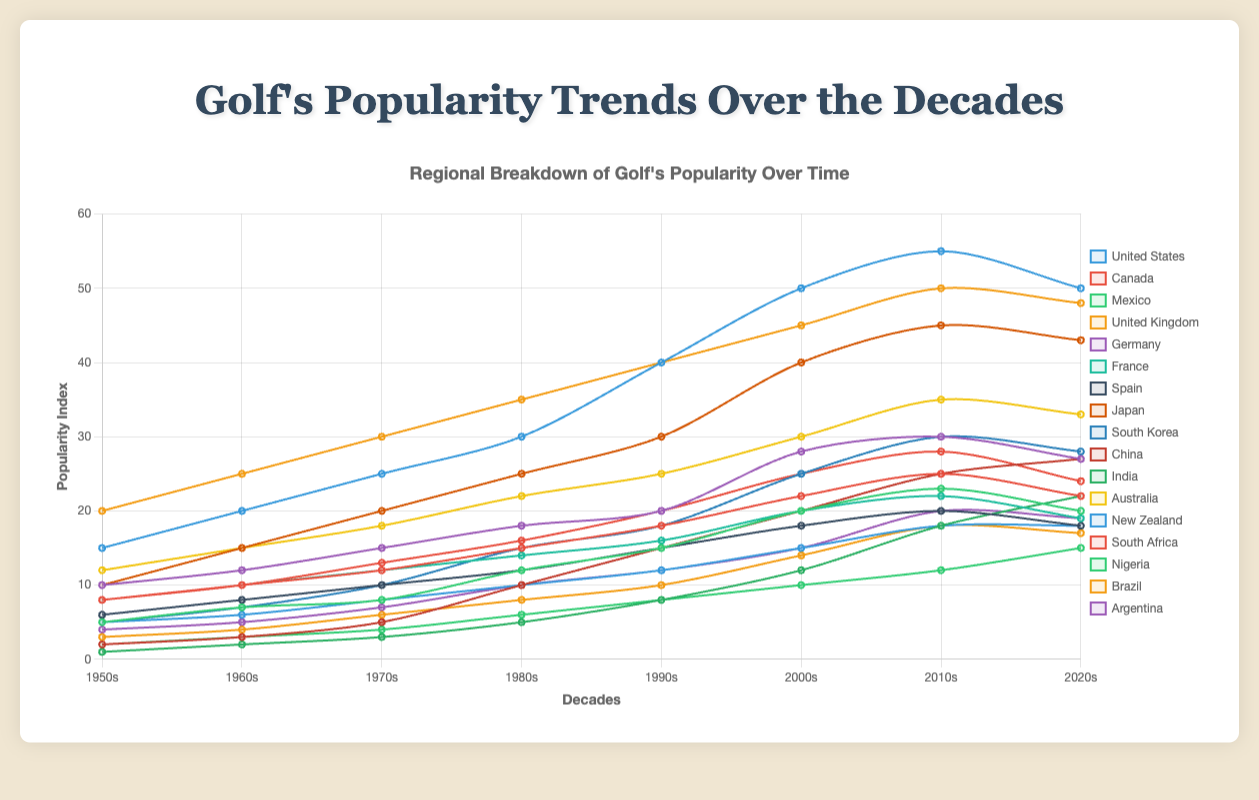What is the general trend of golf's popularity in the United States from the 1950s to the 2020s? From the 1950s to the 2000s, golf's popularity in the United States shows a steady increase, peaking in the 2010s, then slightly declining in the 2020s. Specifically, the popularity index rises from 15 in the 1950s to 55 in the 2010s and drops to 50 in the 2020s.
Answer: Steady increase with a peak in the 2010s and slight decline in the 2020s Which country in Europe saw the highest increase in golf's popularity from the 1950s to the 2020s? To find the highest increase, subtract the 1950s value from the 2020s value for each country in Europe. United Kingdom: 48 - 20 = 28, Germany: 27 - 10 = 17, France: 19 - 8 = 11, Spain: 18 - 6 = 12. The United Kingdom has the highest increase of 28.
Answer: United Kingdom In the 2010s, which region had the country with the highest popularity index in golf? Check the popularity index for each country in the 2010s. The United States (North America) has the highest index at 55.
Answer: North America In which decade did South Korea see the highest increase in golf's popularity? Calculate the difference between each consecutive decade for South Korea. The highest increase is between the 1990s and 2000s, from 18 to 25, i.e., a 7-point increase.
Answer: 1990s to 2000s Which two countries have shown a decrease in golf's popularity from the 2010s to the 2020s? Compare the 2010s and 2020s values for each country. Countries with a decrease are the United States (55 to 50), Canada (25 to 22), Germany (30 to 27), France (22 to 19), Spain (20 to 18), Japan (45 to 43), South Korea (30 to 28), South Africa (28 to 24), Brazil (18 to 17), and Argentina (20 to 19).
Answer: Multiple countries (e.g., United States) In the 2000s, which two countries from different regions have nearly equal golf popularity indexes? Compare the 2000s values for all countries. Canada (22) and France (20) have nearly equal indexes.
Answer: Canada and France What is the difference in golf's popularity between Japan and China in the 2020s? Subtract China's value from Japan's in the 2020s: 43 - 27 = 16.
Answer: 16 By how many points did the popularity of golf increase in Argentina from the 1950s to the 2020s? Subtract the 1950s value from the 2020s value for Argentina: 19 - 4 = 15.
Answer: 15 What is the average popularity index for Australia from the 1950s to the 2020s? Sum Australia's popularity indexes (12 + 15 + 18 + 22 + 25 + 30 + 35 + 33) = 190, then divide by 8 (number of decades), i.e., 190/8 = 23.75.
Answer: 23.75 